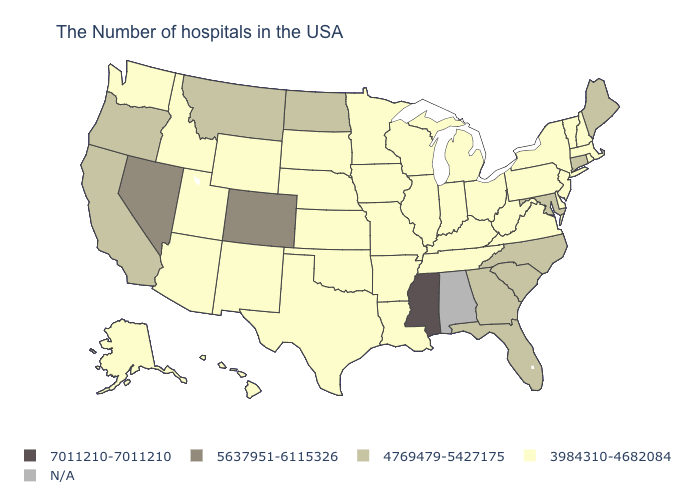Does West Virginia have the highest value in the USA?
Give a very brief answer. No. What is the value of Wyoming?
Give a very brief answer. 3984310-4682084. Name the states that have a value in the range N/A?
Quick response, please. Alabama. What is the value of Maine?
Give a very brief answer. 4769479-5427175. Name the states that have a value in the range N/A?
Give a very brief answer. Alabama. Does Connecticut have the highest value in the Northeast?
Be succinct. Yes. What is the value of Delaware?
Concise answer only. 3984310-4682084. Does the map have missing data?
Short answer required. Yes. What is the value of Kentucky?
Keep it brief. 3984310-4682084. What is the highest value in the USA?
Concise answer only. 7011210-7011210. Does Mississippi have the highest value in the USA?
Answer briefly. Yes. Which states have the lowest value in the USA?
Write a very short answer. Massachusetts, Rhode Island, New Hampshire, Vermont, New York, New Jersey, Delaware, Pennsylvania, Virginia, West Virginia, Ohio, Michigan, Kentucky, Indiana, Tennessee, Wisconsin, Illinois, Louisiana, Missouri, Arkansas, Minnesota, Iowa, Kansas, Nebraska, Oklahoma, Texas, South Dakota, Wyoming, New Mexico, Utah, Arizona, Idaho, Washington, Alaska, Hawaii. Which states have the lowest value in the USA?
Be succinct. Massachusetts, Rhode Island, New Hampshire, Vermont, New York, New Jersey, Delaware, Pennsylvania, Virginia, West Virginia, Ohio, Michigan, Kentucky, Indiana, Tennessee, Wisconsin, Illinois, Louisiana, Missouri, Arkansas, Minnesota, Iowa, Kansas, Nebraska, Oklahoma, Texas, South Dakota, Wyoming, New Mexico, Utah, Arizona, Idaho, Washington, Alaska, Hawaii. Does Arizona have the lowest value in the West?
Write a very short answer. Yes. 